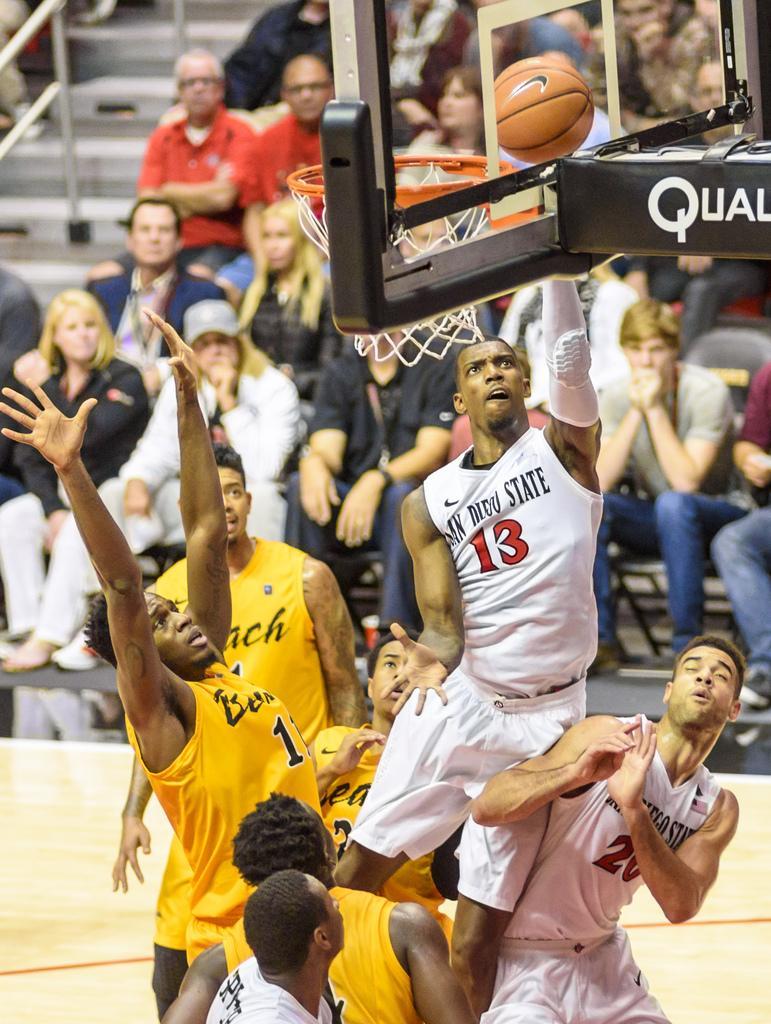Can you describe this image briefly? As we can see in the image there are few people here and there, stairs, net and wall. 